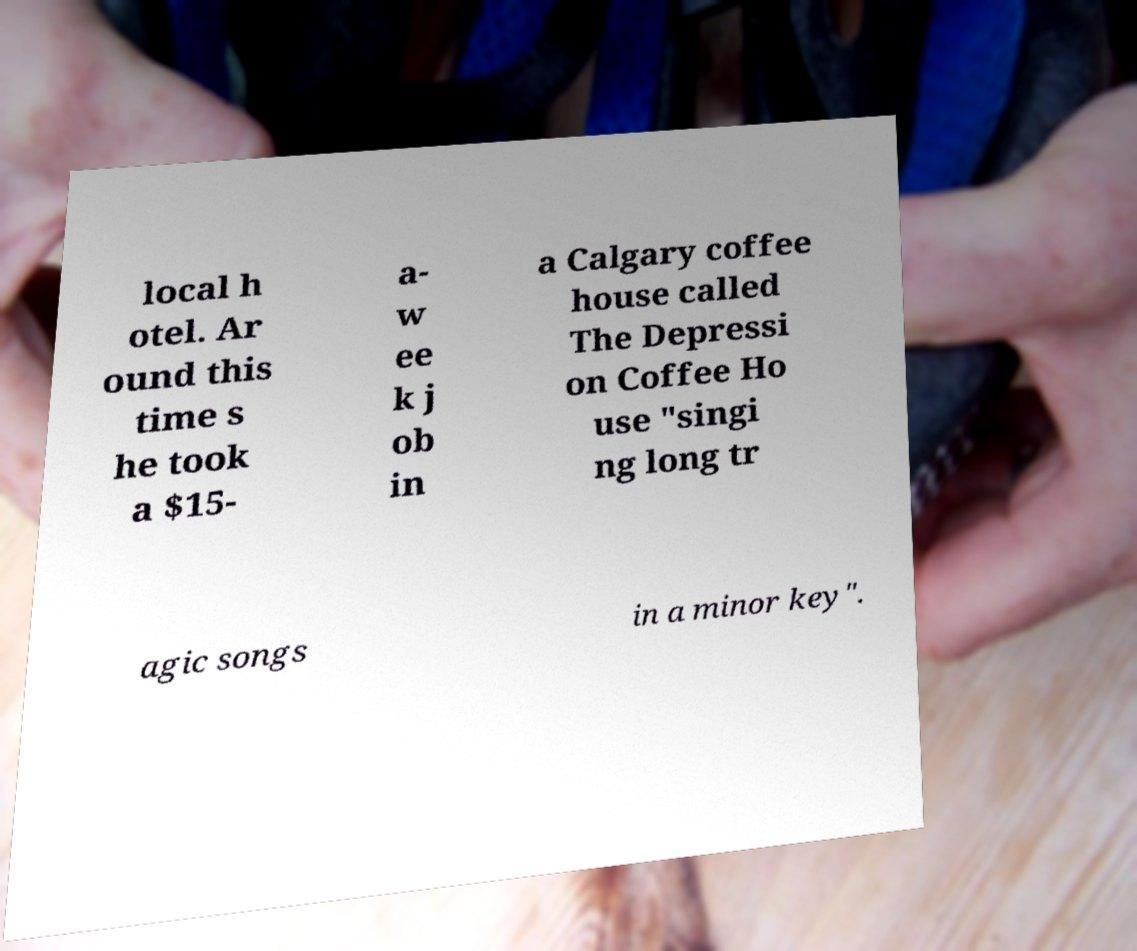Can you accurately transcribe the text from the provided image for me? local h otel. Ar ound this time s he took a $15- a- w ee k j ob in a Calgary coffee house called The Depressi on Coffee Ho use "singi ng long tr agic songs in a minor key". 